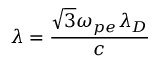<formula> <loc_0><loc_0><loc_500><loc_500>\lambda = \frac { \sqrt { 3 } \omega _ { p e } \lambda _ { D } } { c }</formula> 